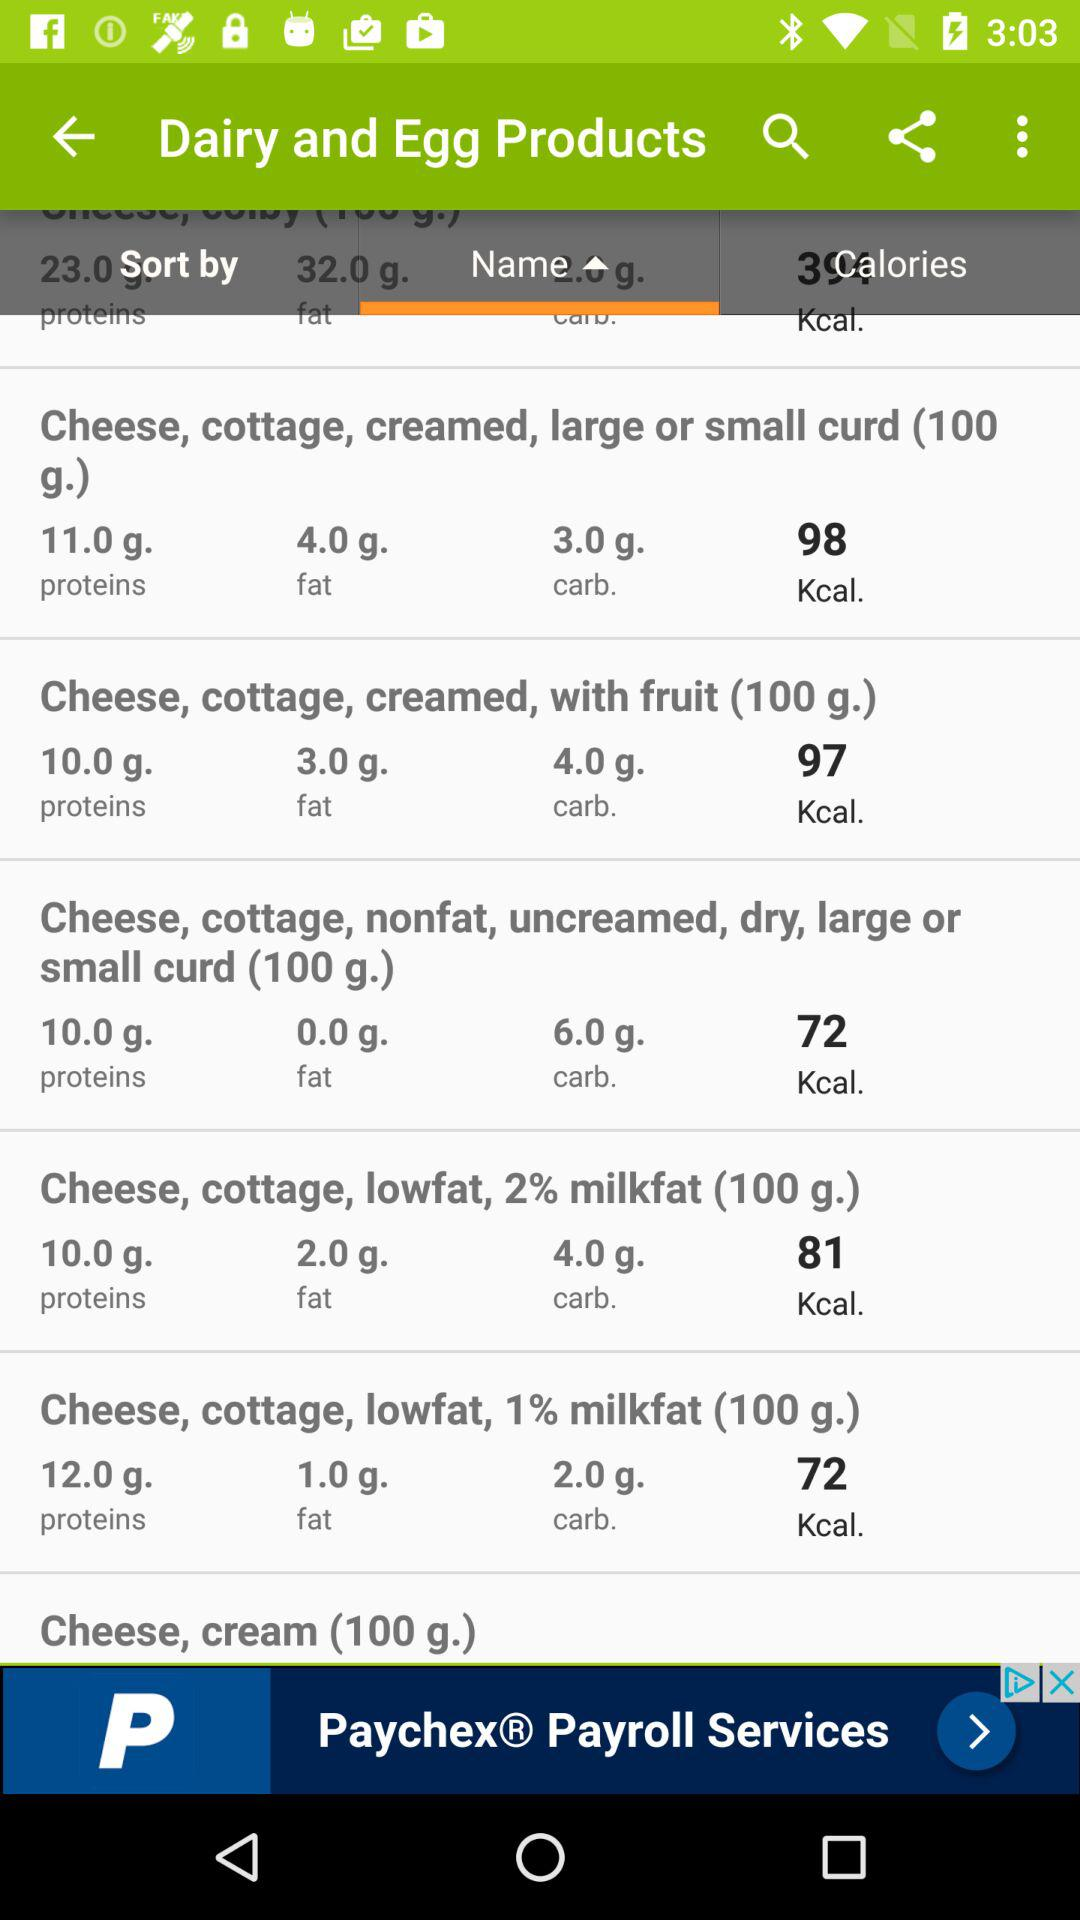How much protein is added to a 100g of cheese, cottage, nonfat, non-creamed, dry, large or small curd? The protein added is 10.0 g. 